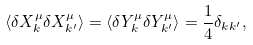<formula> <loc_0><loc_0><loc_500><loc_500>\langle \delta X ^ { \mu } _ { k } \delta X ^ { \mu } _ { k ^ { \prime } } \rangle = \langle \delta Y ^ { \mu } _ { k } \delta Y ^ { \mu } _ { k ^ { \prime } } \rangle = \frac { 1 } { 4 } \delta _ { k k ^ { \prime } } ,</formula> 